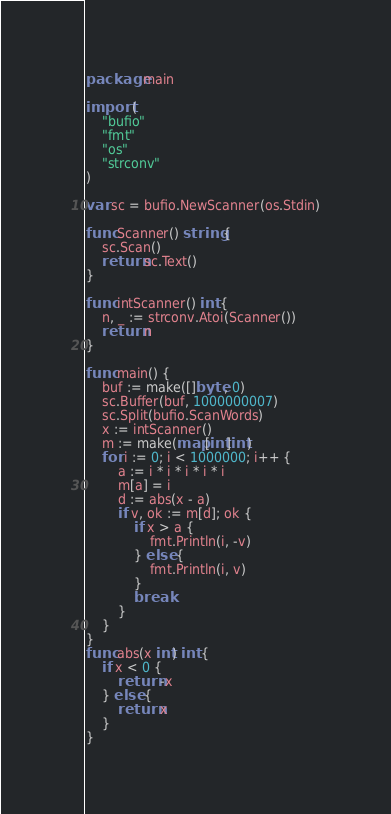Convert code to text. <code><loc_0><loc_0><loc_500><loc_500><_Go_>package main

import (
	"bufio"
	"fmt"
	"os"
	"strconv"
)

var sc = bufio.NewScanner(os.Stdin)

func Scanner() string {
	sc.Scan()
	return sc.Text()
}

func intScanner() int {
	n, _ := strconv.Atoi(Scanner())
	return n
}

func main() {
	buf := make([]byte, 0)
	sc.Buffer(buf, 1000000007)
	sc.Split(bufio.ScanWords)
	x := intScanner()
	m := make(map[int]int)
	for i := 0; i < 1000000; i++ {
		a := i * i * i * i * i
		m[a] = i
		d := abs(x - a)
		if v, ok := m[d]; ok {
			if x > a {
				fmt.Println(i, -v)
			} else {
				fmt.Println(i, v)
			}
			break
		}
	}
}
func abs(x int) int {
	if x < 0 {
		return -x
	} else {
		return x
	}
}
</code> 